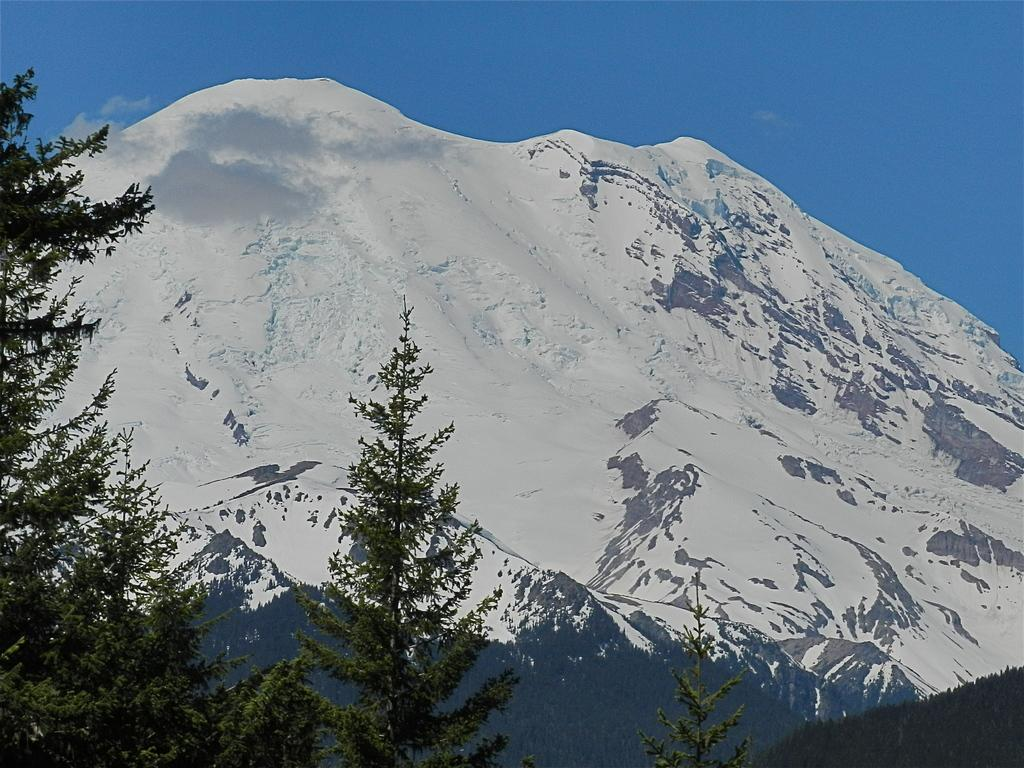What type of natural formation can be seen in the image? There is a mountain in the image. What other natural elements are present in the image? There is a group of trees in the image. What can be seen above the mountain and trees? The sky is visible in the image. What type of pencil can be seen in the image? There is no pencil present in the image. What type of brass instrument is being played in the image? There is no brass instrument or any musical instrument being played in the image. 